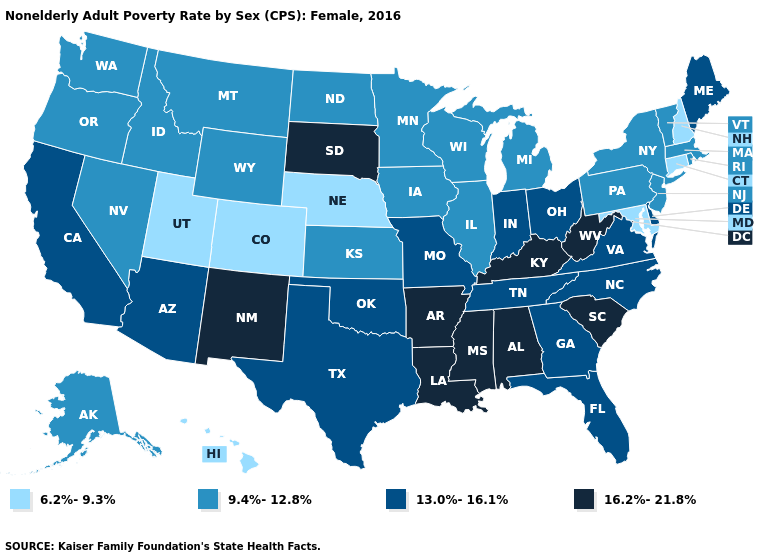Name the states that have a value in the range 13.0%-16.1%?
Give a very brief answer. Arizona, California, Delaware, Florida, Georgia, Indiana, Maine, Missouri, North Carolina, Ohio, Oklahoma, Tennessee, Texas, Virginia. What is the value of Virginia?
Be succinct. 13.0%-16.1%. What is the value of Texas?
Write a very short answer. 13.0%-16.1%. Name the states that have a value in the range 16.2%-21.8%?
Keep it brief. Alabama, Arkansas, Kentucky, Louisiana, Mississippi, New Mexico, South Carolina, South Dakota, West Virginia. Does Massachusetts have the same value as Nevada?
Write a very short answer. Yes. What is the highest value in the MidWest ?
Give a very brief answer. 16.2%-21.8%. Which states have the lowest value in the USA?
Keep it brief. Colorado, Connecticut, Hawaii, Maryland, Nebraska, New Hampshire, Utah. Name the states that have a value in the range 9.4%-12.8%?
Short answer required. Alaska, Idaho, Illinois, Iowa, Kansas, Massachusetts, Michigan, Minnesota, Montana, Nevada, New Jersey, New York, North Dakota, Oregon, Pennsylvania, Rhode Island, Vermont, Washington, Wisconsin, Wyoming. Name the states that have a value in the range 13.0%-16.1%?
Give a very brief answer. Arizona, California, Delaware, Florida, Georgia, Indiana, Maine, Missouri, North Carolina, Ohio, Oklahoma, Tennessee, Texas, Virginia. What is the lowest value in the USA?
Concise answer only. 6.2%-9.3%. Name the states that have a value in the range 9.4%-12.8%?
Be succinct. Alaska, Idaho, Illinois, Iowa, Kansas, Massachusetts, Michigan, Minnesota, Montana, Nevada, New Jersey, New York, North Dakota, Oregon, Pennsylvania, Rhode Island, Vermont, Washington, Wisconsin, Wyoming. Is the legend a continuous bar?
Be succinct. No. Does Maine have the same value as South Dakota?
Be succinct. No. What is the highest value in the USA?
Quick response, please. 16.2%-21.8%. Does Minnesota have a higher value than South Dakota?
Write a very short answer. No. 